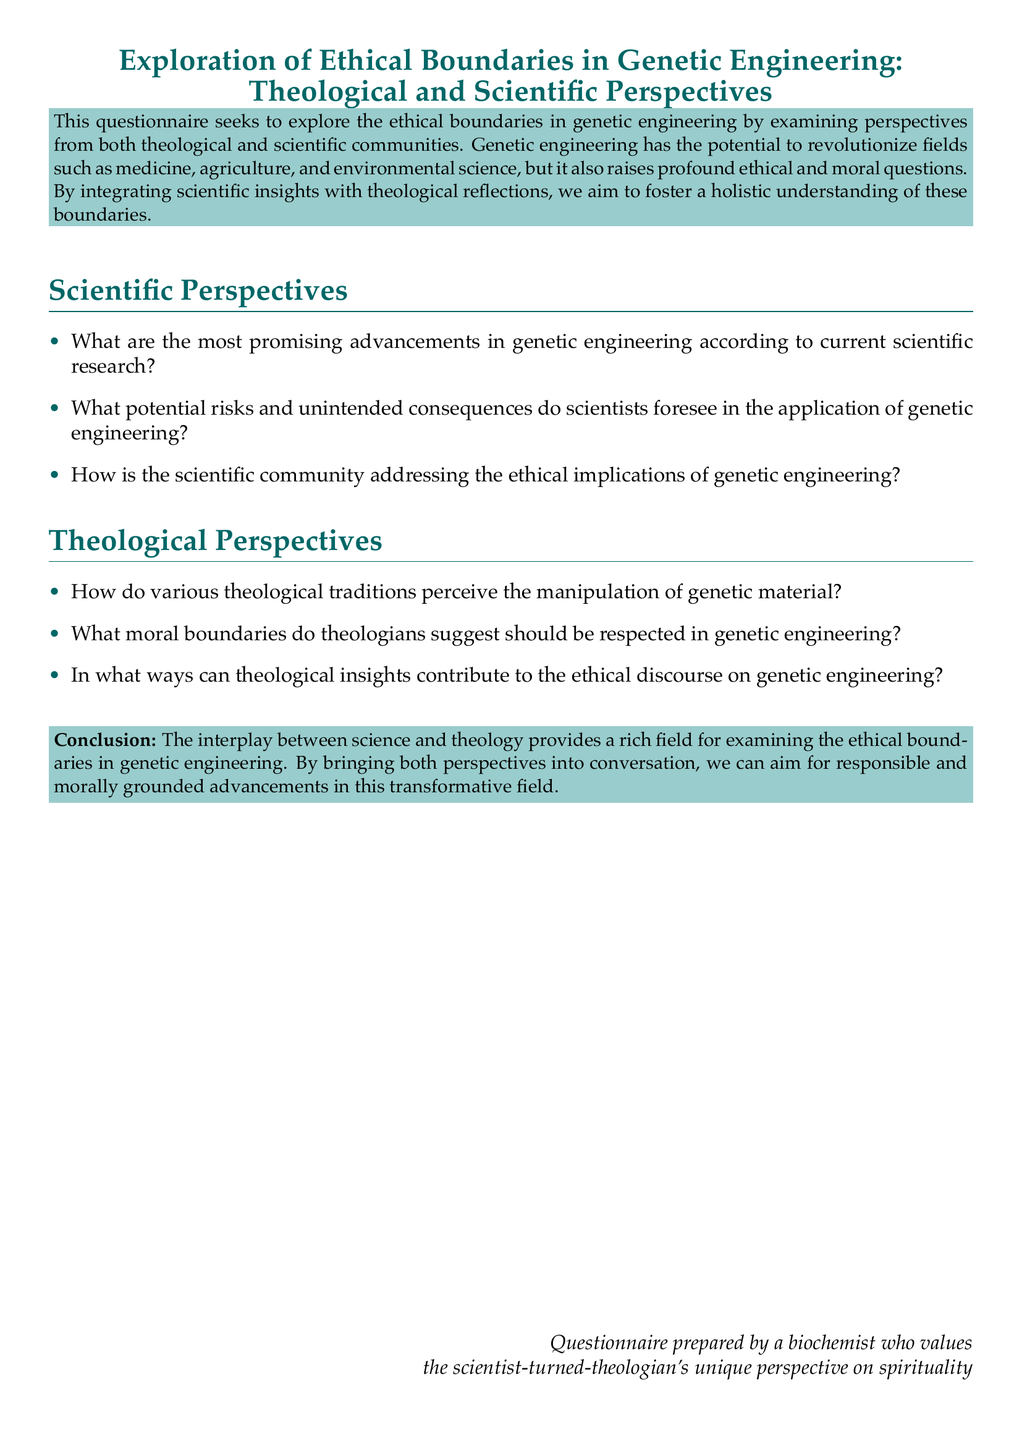What is the title of the document? The title of the document is provided at the beginning and states "Exploration of Ethical Boundaries in Genetic Engineering: Theological and Scientific Perspectives."
Answer: Exploration of Ethical Boundaries in Genetic Engineering: Theological and Scientific Perspectives What color is used for the main text? The document specifies a color defined as "maincolor," which is represented in RGB values and appears throughout the text.
Answer: RGB(0,102,102) How many sections are included in the scientific perspectives? The document lists three specific questions under the "Scientific Perspectives" section.
Answer: 3 What is the color of the box that contains the conclusion? The conclusion is enclosed in a colored box defined as "secondcolor."
Answer: secondcolor What does the questionnaire aim to explore? The questionnaire explicitly states its aim to explore ethical boundaries in genetic engineering from both theological and scientific perspectives.
Answer: Ethical boundaries in genetic engineering How do theologians view genetic material manipulation? The document poses this question under the "Theological Perspectives" section, indicating that there are varying views among theological traditions.
Answer: Varying views Which community is responsible for addressing ethical implications in genetic engineering? The document asks how the scientific community is addressing the ethical implications of genetic engineering.
Answer: Scientific community What type of insights can contribute to the ethical discourse? The document states that theological insights can contribute to the ethical discourse on genetic engineering.
Answer: Theological insights 